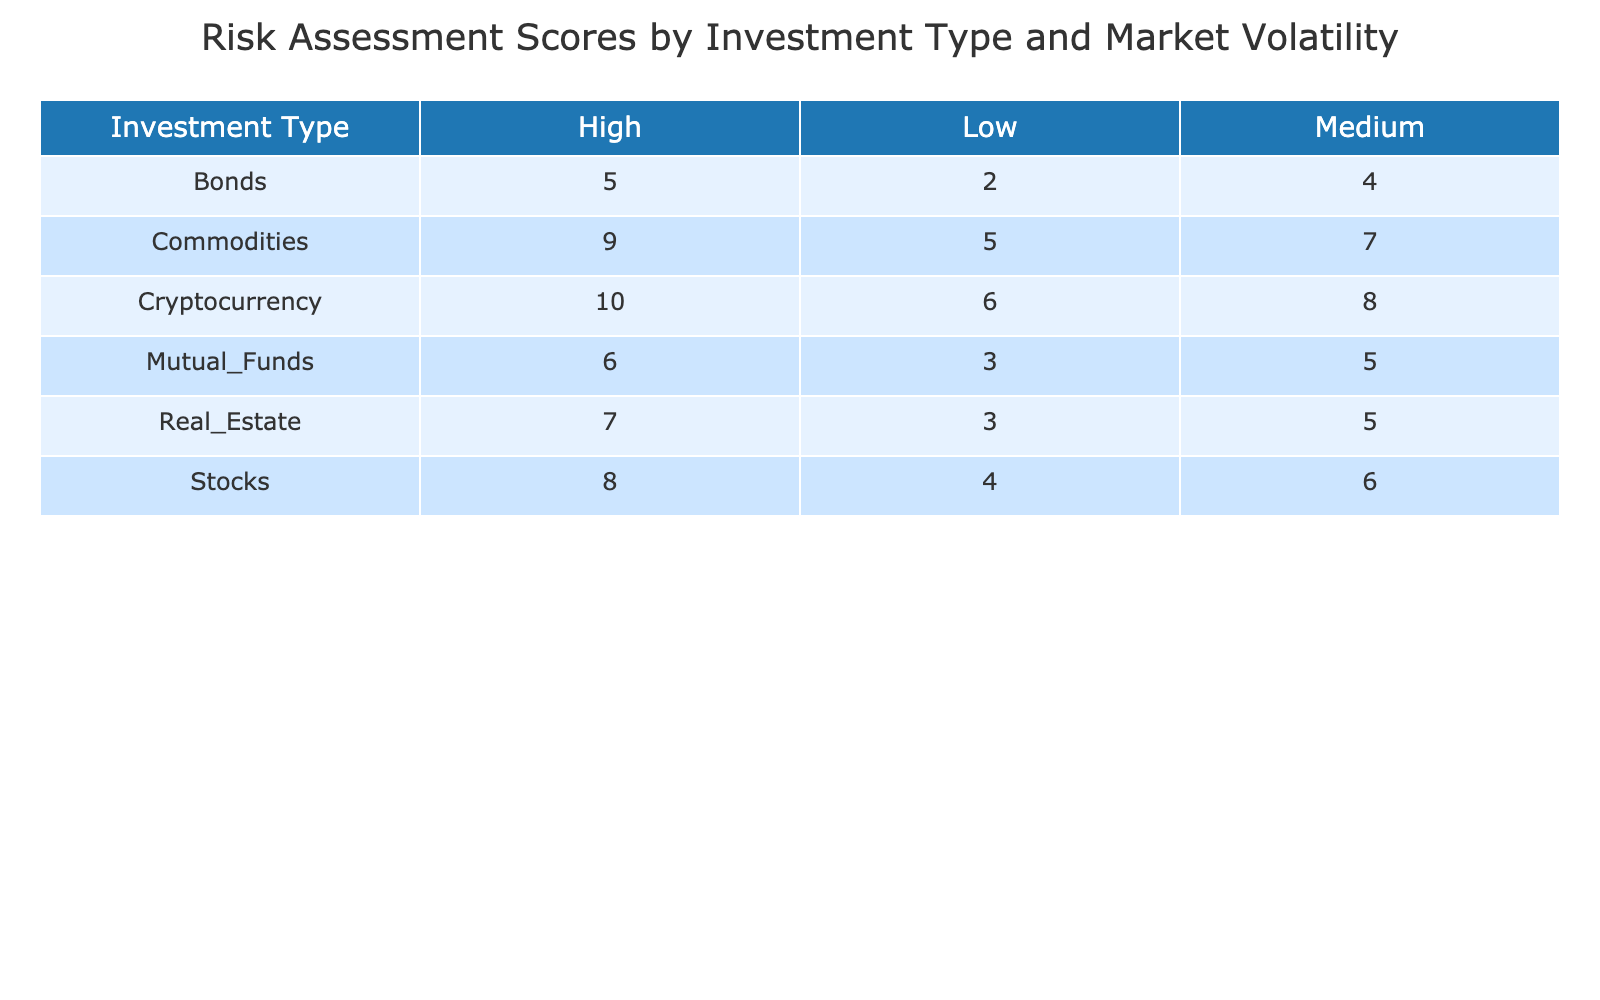What is the risk assessment score for Stocks under Medium market volatility? Referring to the table, the risk assessment score for Stocks under Medium market volatility is directly displayed in the relevant cell. It shows a score of 6.
Answer: 6 What is the highest risk assessment score across all investment types? To find the highest score, I need to check all values in the table. The highest score is identified as 10, which corresponds to Cryptocurrency under High market volatility.
Answer: 10 Do Bonds have a lower risk assessment score under Low market volatility compared to Real Estate? By comparing the scores in the table, Bonds under Low market volatility have a score of 2, while Real Estate has a score of 3. Since 2 is lower than 3, the answer is yes.
Answer: Yes What is the average risk assessment score for Commodities across all market volatility levels? First, I need to sum the Commodities scores for each volatility level: High (9), Medium (7), and Low (5). This gives us a total of 9 + 7 + 5 = 21. Then, I divide this sum by the number of entries (3): 21 / 3 = 7.
Answer: 7 Which investment type has the lowest risk assessment score under High market volatility? By examining the scores for the High market volatility column, I can see: Stocks (8), Bonds (5), Real Estate (7), Commodities (9), Cryptocurrency (10), and Mutual Funds (6). The lowest among these values is 5, which belongs to Bonds.
Answer: Bonds If I combine the risk assessment scores for Stocks and Real Estate under Medium market volatility, what would be the total? Looking at the Medium column for both investments, Stocks have a score of 6, and Real Estate has a score of 5. Adding these scores gives us a total of 6 + 5 = 11.
Answer: 11 Are all investment types scoring above the average risk assessment score of 5 under Low market volatility? The scores under Low market volatility are: Stocks (4), Bonds (2), Real Estate (3), Commodities (5), Cryptocurrency (6), and Mutual Funds (3). Notably, Stocks (4), Bonds (2), and Real Estate (3) all do not exceed the average score of 5. Thus, the answer is no.
Answer: No What is the difference between the highest and lowest risk assessment scores for Cryptocurrency? The risk assessment scores for Cryptocurrency are: High (10), Medium (8), and Low (6). The highest score is 10 and the lowest is 6. By calculating the difference: 10 - 6 = 4, we find the answer.
Answer: 4 What is the risk profile trend of Mutual Funds as market volatility decreases? Checking the scores for Mutual Funds across different volatility levels shows: High (6), Medium (5), and Low (3). As volatility decreases, the scores decrease from 6 to 5 to 3, indicating a downward trend.
Answer: Downward trend 